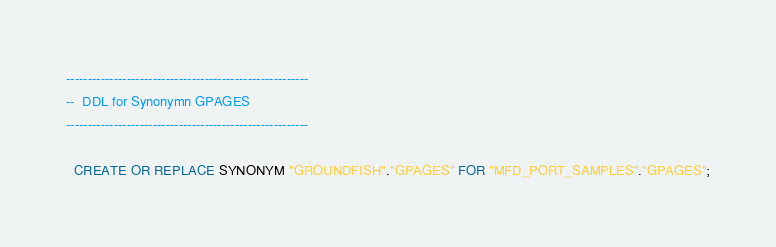Convert code to text. <code><loc_0><loc_0><loc_500><loc_500><_SQL_>--------------------------------------------------------
--  DDL for Synonymn GPAGES
--------------------------------------------------------

  CREATE OR REPLACE SYNONYM "GROUNDFISH"."GPAGES" FOR "MFD_PORT_SAMPLES"."GPAGES";
</code> 